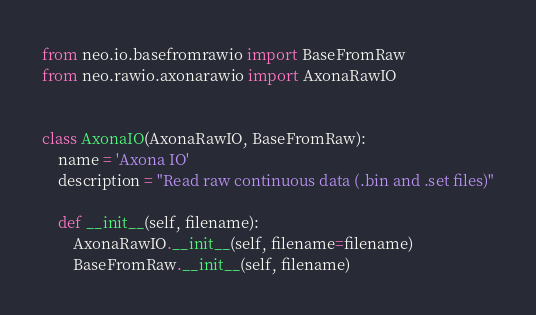<code> <loc_0><loc_0><loc_500><loc_500><_Python_>from neo.io.basefromrawio import BaseFromRaw
from neo.rawio.axonarawio import AxonaRawIO


class AxonaIO(AxonaRawIO, BaseFromRaw):
    name = 'Axona IO'
    description = "Read raw continuous data (.bin and .set files)"

    def __init__(self, filename):
        AxonaRawIO.__init__(self, filename=filename)
        BaseFromRaw.__init__(self, filename)
</code> 